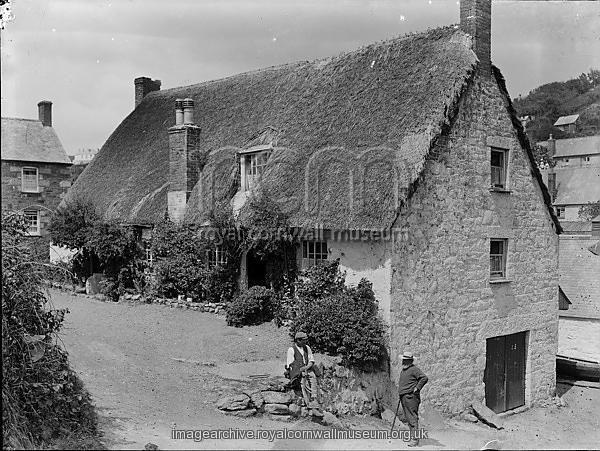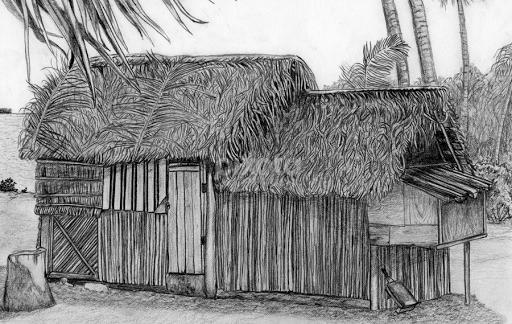The first image is the image on the left, the second image is the image on the right. For the images shown, is this caption "Two houses have chimneys." true? Answer yes or no. No. The first image is the image on the left, the second image is the image on the right. Examine the images to the left and right. Is the description "The right image features palm trees behind at least one primitive structure with a peaked thatch roof." accurate? Answer yes or no. Yes. 